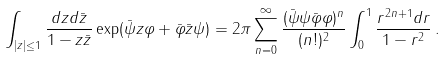<formula> <loc_0><loc_0><loc_500><loc_500>\int _ { | z | \leq 1 } \frac { d z d \bar { z } } { 1 - z \bar { z } } \exp ( \bar { \psi } z \varphi + \bar { \varphi } \bar { z } \psi ) = 2 \pi \sum _ { n = 0 } ^ { \infty } \frac { ( \bar { \psi } \psi \bar { \varphi } \varphi ) ^ { n } } { ( n ! ) ^ { 2 } } \int _ { 0 } ^ { 1 } \frac { r ^ { 2 n + 1 } d r } { 1 - r ^ { 2 } } \, .</formula> 